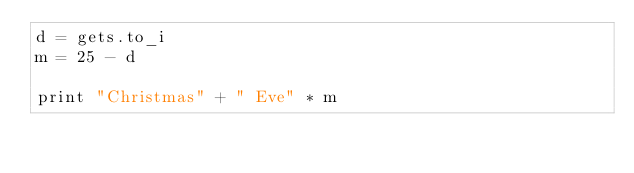Convert code to text. <code><loc_0><loc_0><loc_500><loc_500><_Ruby_>d = gets.to_i
m = 25 - d

print "Christmas" + " Eve" * m</code> 